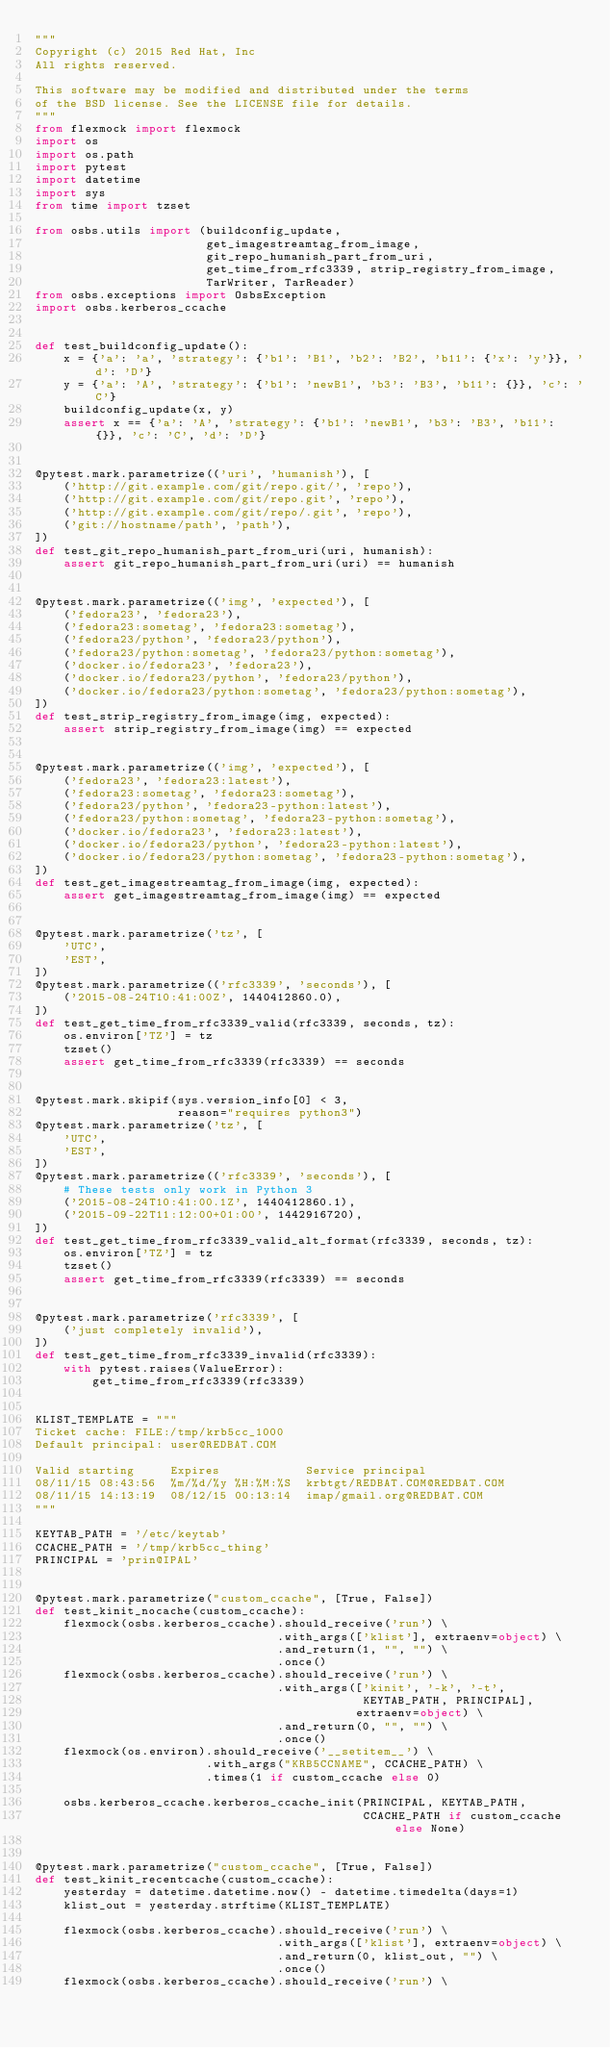<code> <loc_0><loc_0><loc_500><loc_500><_Python_>"""
Copyright (c) 2015 Red Hat, Inc
All rights reserved.

This software may be modified and distributed under the terms
of the BSD license. See the LICENSE file for details.
"""
from flexmock import flexmock
import os
import os.path
import pytest
import datetime
import sys
from time import tzset

from osbs.utils import (buildconfig_update,
                        get_imagestreamtag_from_image,
                        git_repo_humanish_part_from_uri,
                        get_time_from_rfc3339, strip_registry_from_image,
                        TarWriter, TarReader)
from osbs.exceptions import OsbsException
import osbs.kerberos_ccache


def test_buildconfig_update():
    x = {'a': 'a', 'strategy': {'b1': 'B1', 'b2': 'B2', 'b11': {'x': 'y'}}, 'd': 'D'}
    y = {'a': 'A', 'strategy': {'b1': 'newB1', 'b3': 'B3', 'b11': {}}, 'c': 'C'}
    buildconfig_update(x, y)
    assert x == {'a': 'A', 'strategy': {'b1': 'newB1', 'b3': 'B3', 'b11': {}}, 'c': 'C', 'd': 'D'}


@pytest.mark.parametrize(('uri', 'humanish'), [
    ('http://git.example.com/git/repo.git/', 'repo'),
    ('http://git.example.com/git/repo.git', 'repo'),
    ('http://git.example.com/git/repo/.git', 'repo'),
    ('git://hostname/path', 'path'),
])
def test_git_repo_humanish_part_from_uri(uri, humanish):
    assert git_repo_humanish_part_from_uri(uri) == humanish


@pytest.mark.parametrize(('img', 'expected'), [
    ('fedora23', 'fedora23'),
    ('fedora23:sometag', 'fedora23:sometag'),
    ('fedora23/python', 'fedora23/python'),
    ('fedora23/python:sometag', 'fedora23/python:sometag'),
    ('docker.io/fedora23', 'fedora23'),
    ('docker.io/fedora23/python', 'fedora23/python'),
    ('docker.io/fedora23/python:sometag', 'fedora23/python:sometag'),
])
def test_strip_registry_from_image(img, expected):
    assert strip_registry_from_image(img) == expected


@pytest.mark.parametrize(('img', 'expected'), [
    ('fedora23', 'fedora23:latest'),
    ('fedora23:sometag', 'fedora23:sometag'),
    ('fedora23/python', 'fedora23-python:latest'),
    ('fedora23/python:sometag', 'fedora23-python:sometag'),
    ('docker.io/fedora23', 'fedora23:latest'),
    ('docker.io/fedora23/python', 'fedora23-python:latest'),
    ('docker.io/fedora23/python:sometag', 'fedora23-python:sometag'),
])
def test_get_imagestreamtag_from_image(img, expected):
    assert get_imagestreamtag_from_image(img) == expected


@pytest.mark.parametrize('tz', [
    'UTC',
    'EST',
])
@pytest.mark.parametrize(('rfc3339', 'seconds'), [
    ('2015-08-24T10:41:00Z', 1440412860.0),
])
def test_get_time_from_rfc3339_valid(rfc3339, seconds, tz):
    os.environ['TZ'] = tz
    tzset()
    assert get_time_from_rfc3339(rfc3339) == seconds


@pytest.mark.skipif(sys.version_info[0] < 3,
                    reason="requires python3")
@pytest.mark.parametrize('tz', [
    'UTC',
    'EST',
])
@pytest.mark.parametrize(('rfc3339', 'seconds'), [
    # These tests only work in Python 3
    ('2015-08-24T10:41:00.1Z', 1440412860.1),
    ('2015-09-22T11:12:00+01:00', 1442916720),
])
def test_get_time_from_rfc3339_valid_alt_format(rfc3339, seconds, tz):
    os.environ['TZ'] = tz
    tzset()
    assert get_time_from_rfc3339(rfc3339) == seconds


@pytest.mark.parametrize('rfc3339', [
    ('just completely invalid'),
])
def test_get_time_from_rfc3339_invalid(rfc3339):
    with pytest.raises(ValueError):
        get_time_from_rfc3339(rfc3339)


KLIST_TEMPLATE = """
Ticket cache: FILE:/tmp/krb5cc_1000
Default principal: user@REDBAT.COM

Valid starting     Expires            Service principal
08/11/15 08:43:56  %m/%d/%y %H:%M:%S  krbtgt/REDBAT.COM@REDBAT.COM
08/11/15 14:13:19  08/12/15 00:13:14  imap/gmail.org@REDBAT.COM
"""

KEYTAB_PATH = '/etc/keytab'
CCACHE_PATH = '/tmp/krb5cc_thing'
PRINCIPAL = 'prin@IPAL'


@pytest.mark.parametrize("custom_ccache", [True, False])
def test_kinit_nocache(custom_ccache):
    flexmock(osbs.kerberos_ccache).should_receive('run') \
                                  .with_args(['klist'], extraenv=object) \
                                  .and_return(1, "", "") \
                                  .once()
    flexmock(osbs.kerberos_ccache).should_receive('run') \
                                  .with_args(['kinit', '-k', '-t',
                                              KEYTAB_PATH, PRINCIPAL],
                                             extraenv=object) \
                                  .and_return(0, "", "") \
                                  .once()
    flexmock(os.environ).should_receive('__setitem__') \
                        .with_args("KRB5CCNAME", CCACHE_PATH) \
                        .times(1 if custom_ccache else 0)

    osbs.kerberos_ccache.kerberos_ccache_init(PRINCIPAL, KEYTAB_PATH,
                                              CCACHE_PATH if custom_ccache else None)


@pytest.mark.parametrize("custom_ccache", [True, False])
def test_kinit_recentcache(custom_ccache):
    yesterday = datetime.datetime.now() - datetime.timedelta(days=1)
    klist_out = yesterday.strftime(KLIST_TEMPLATE)

    flexmock(osbs.kerberos_ccache).should_receive('run') \
                                  .with_args(['klist'], extraenv=object) \
                                  .and_return(0, klist_out, "") \
                                  .once()
    flexmock(osbs.kerberos_ccache).should_receive('run') \</code> 